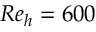<formula> <loc_0><loc_0><loc_500><loc_500>R e _ { h } = 6 0 0</formula> 